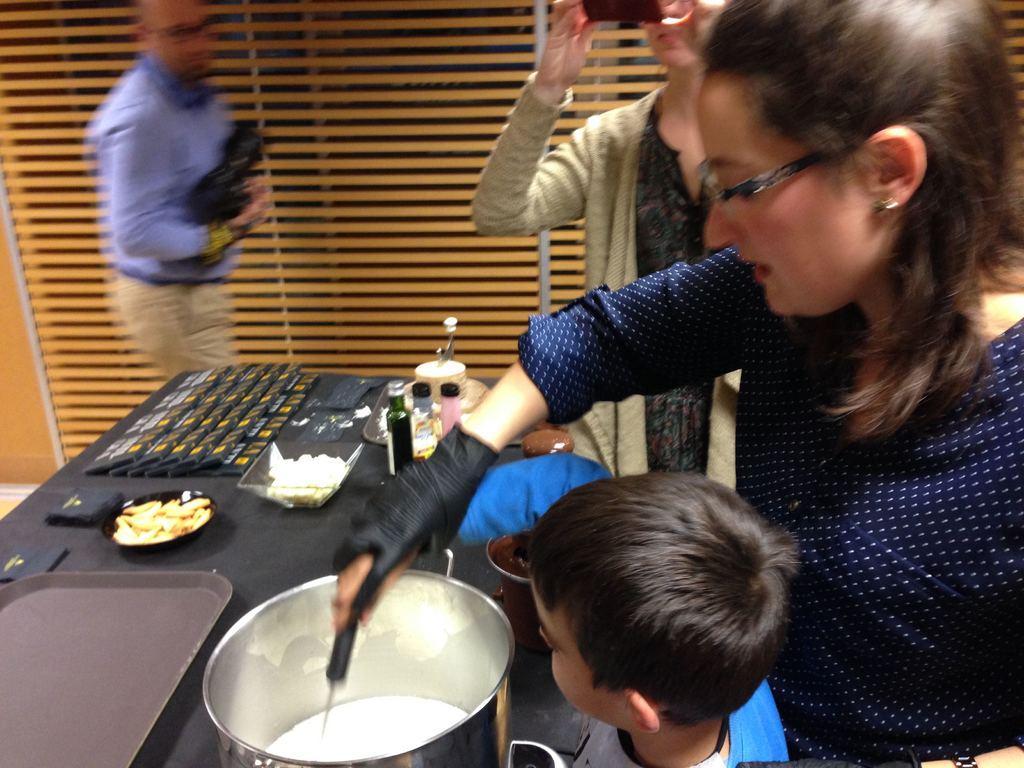In one or two sentences, can you explain what this image depicts? In this picture we can see few people, in front we can see the table on it few objects are placed along with some eatables things. p 